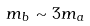<formula> <loc_0><loc_0><loc_500><loc_500>m _ { b } \sim 3 m _ { a }</formula> 